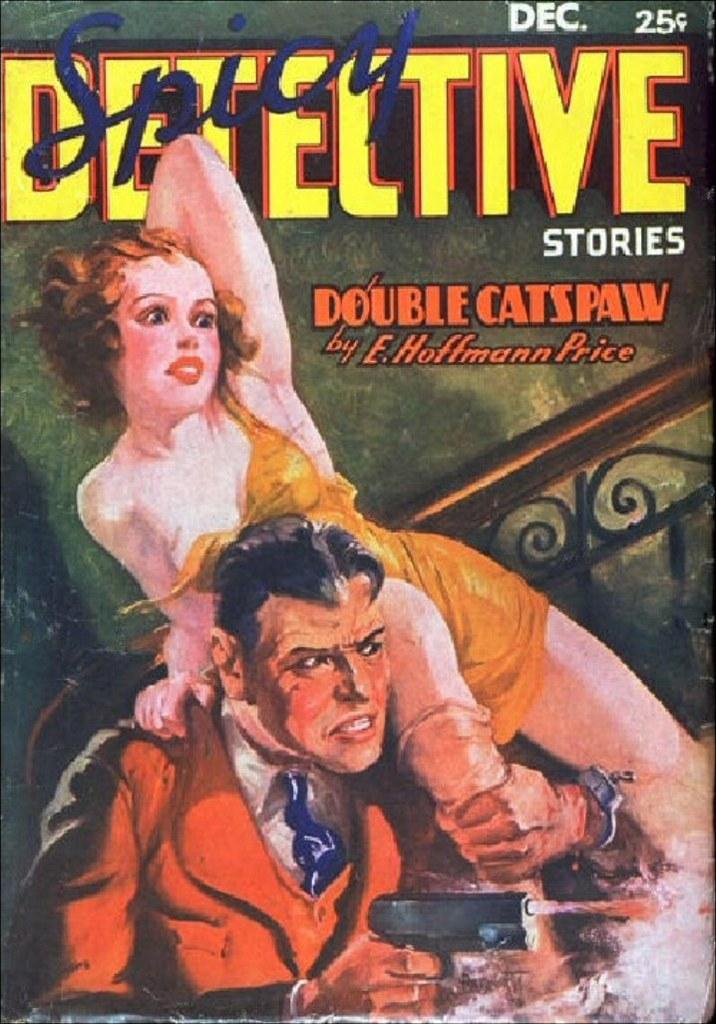What is the title of this detective story?
Your response must be concise. Double catspaw. Who is the book by?
Provide a short and direct response. E. hoffmann price. 